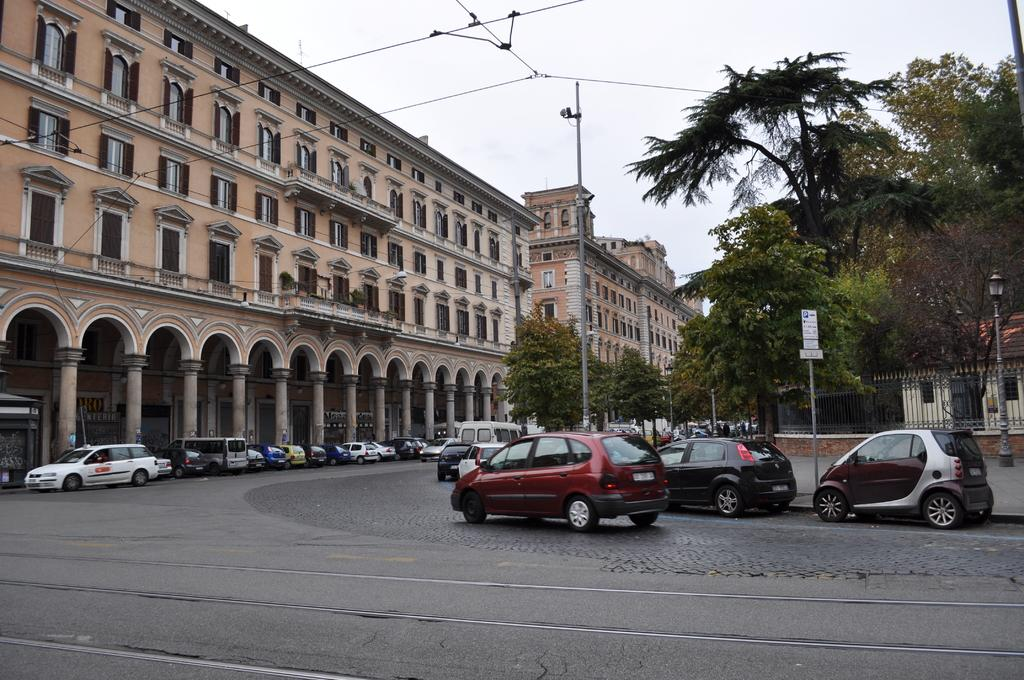What type of vehicles can be seen on the road in the image? There are motor vehicles on the road in the image. What structures are present in the image? There are buildings, pillars, poles, and street poles in the image. What security features are visible in the image? There are CCTV cameras in the image. What infrastructure elements can be seen in the image? There are electric cables, mesh, and street lights in the image. What type of vegetation is present in the image? There are trees in the image. What part of the natural environment is visible in the image? The sky is visible in the image. What type of wood can be seen in the image? There is no wood present in the image. What range of motion can be observed in the ants in the image? There are no ants present in the image. 